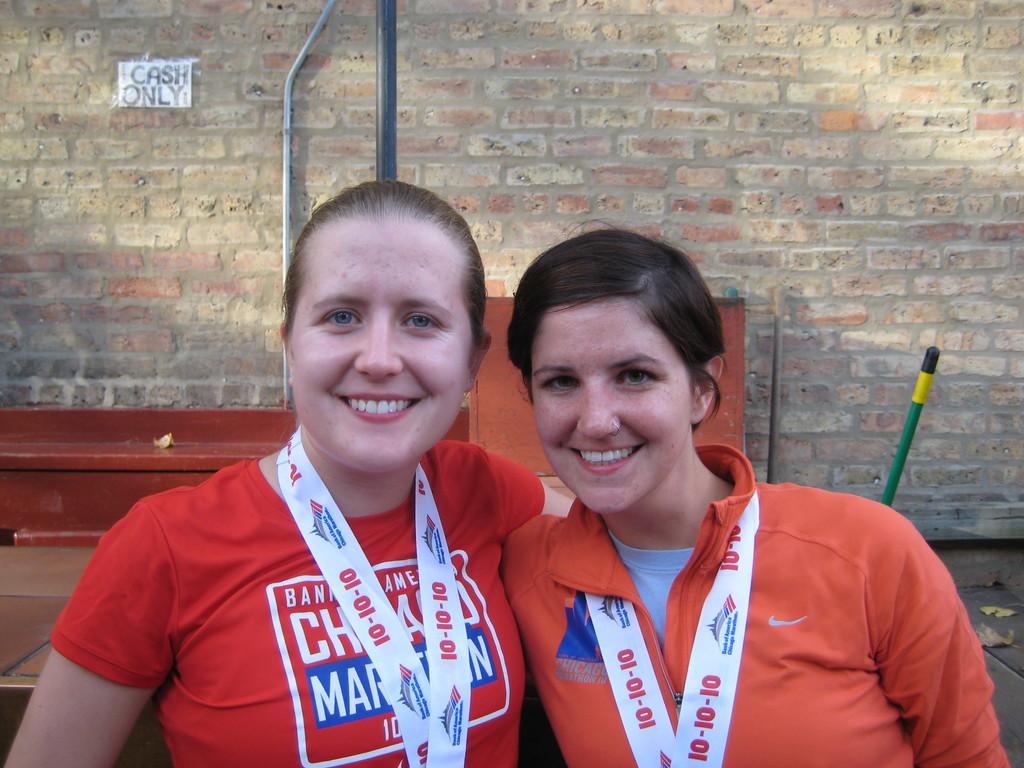What is the date of the marathon?
Your response must be concise. 10-10-10. What form of payment is the only one acceptable, according to the small sign on the wall?
Your response must be concise. Cash. 